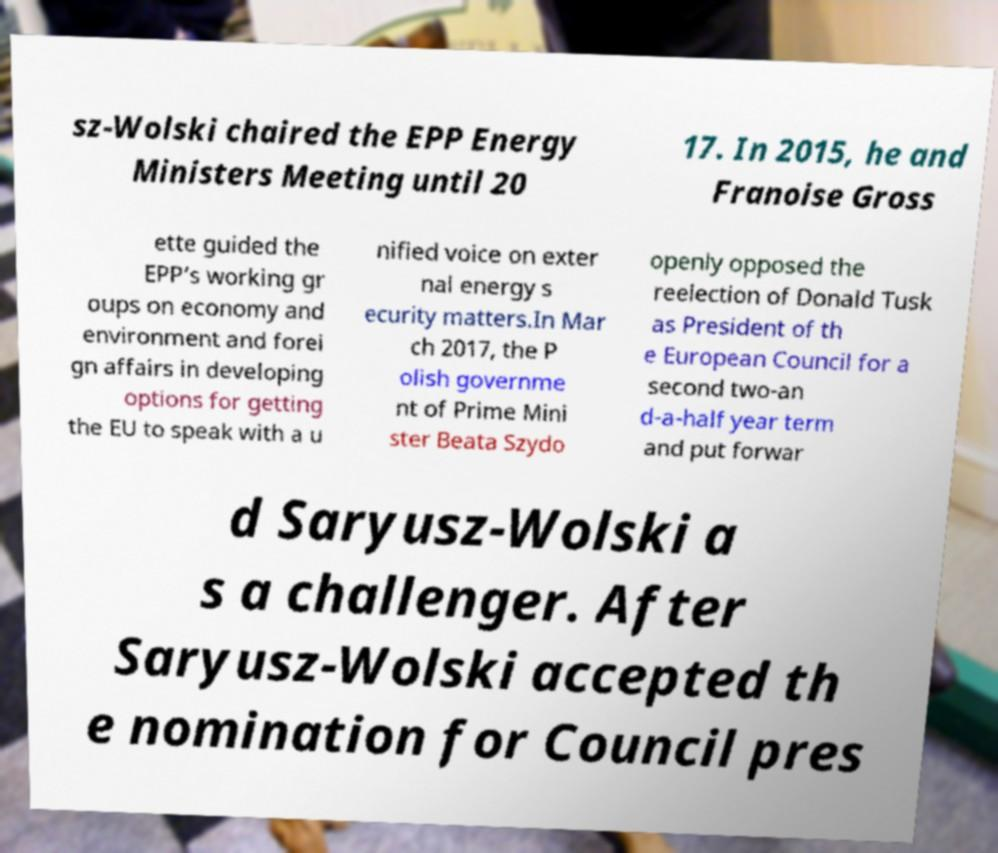What messages or text are displayed in this image? I need them in a readable, typed format. sz-Wolski chaired the EPP Energy Ministers Meeting until 20 17. In 2015, he and Franoise Gross ette guided the EPP’s working gr oups on economy and environment and forei gn affairs in developing options for getting the EU to speak with a u nified voice on exter nal energy s ecurity matters.In Mar ch 2017, the P olish governme nt of Prime Mini ster Beata Szydo openly opposed the reelection of Donald Tusk as President of th e European Council for a second two-an d-a-half year term and put forwar d Saryusz-Wolski a s a challenger. After Saryusz-Wolski accepted th e nomination for Council pres 